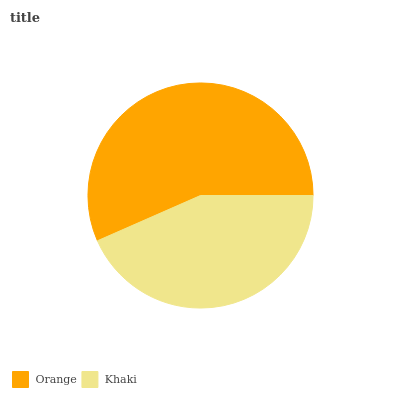Is Khaki the minimum?
Answer yes or no. Yes. Is Orange the maximum?
Answer yes or no. Yes. Is Khaki the maximum?
Answer yes or no. No. Is Orange greater than Khaki?
Answer yes or no. Yes. Is Khaki less than Orange?
Answer yes or no. Yes. Is Khaki greater than Orange?
Answer yes or no. No. Is Orange less than Khaki?
Answer yes or no. No. Is Orange the high median?
Answer yes or no. Yes. Is Khaki the low median?
Answer yes or no. Yes. Is Khaki the high median?
Answer yes or no. No. Is Orange the low median?
Answer yes or no. No. 